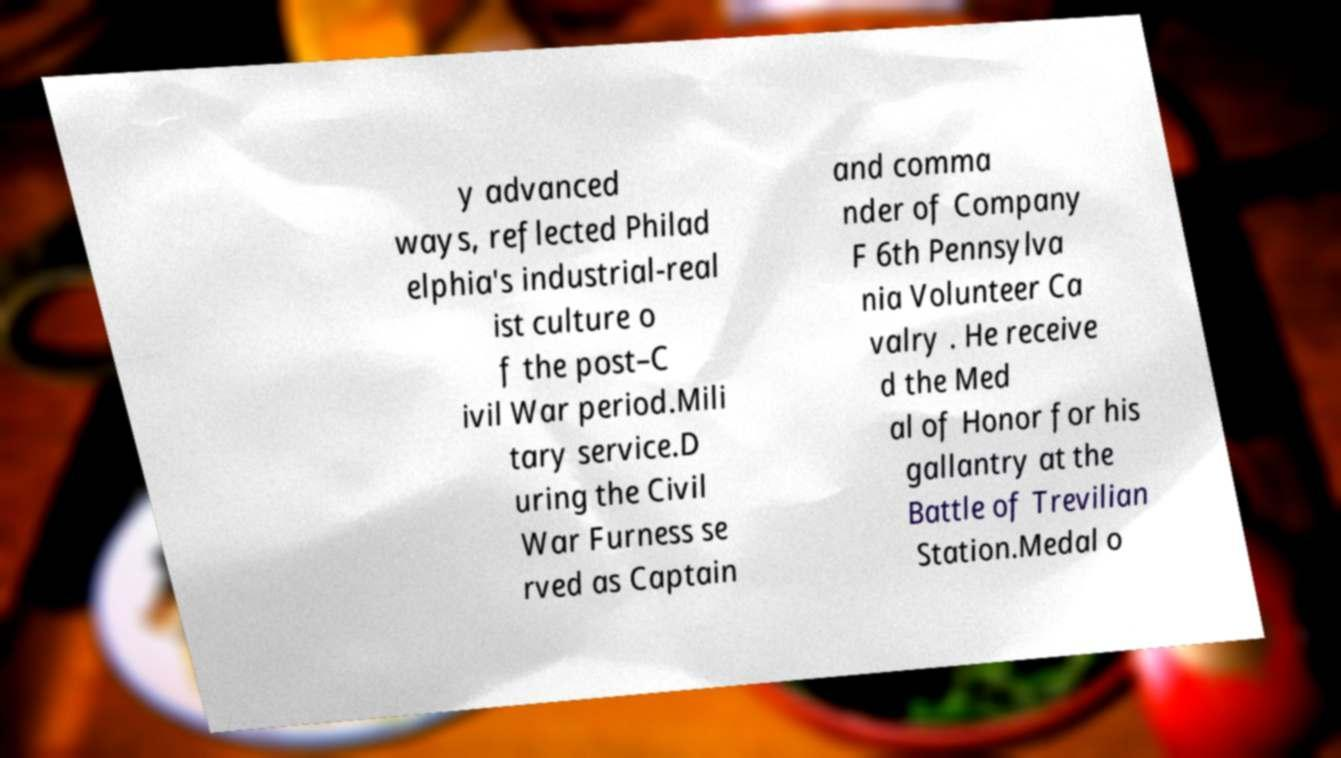Could you extract and type out the text from this image? y advanced ways, reflected Philad elphia's industrial-real ist culture o f the post–C ivil War period.Mili tary service.D uring the Civil War Furness se rved as Captain and comma nder of Company F 6th Pennsylva nia Volunteer Ca valry . He receive d the Med al of Honor for his gallantry at the Battle of Trevilian Station.Medal o 